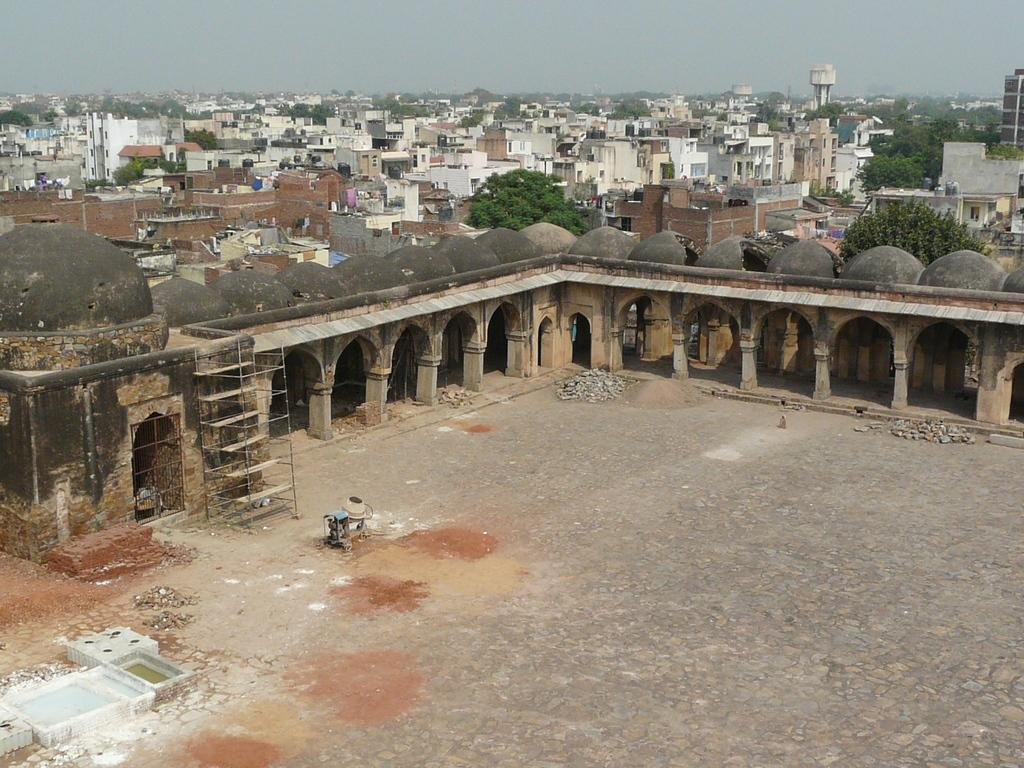What is located in the center of the image? There are stones, bricks, water, and a machine in the center of the image. What can be seen in the background of the image? The sky, buildings, trees, and pillars are visible in the background of the image. How many sheep are present in the image? There are no sheep present in the image. What type of flag is visible in the image? There is no flag present in the image. 